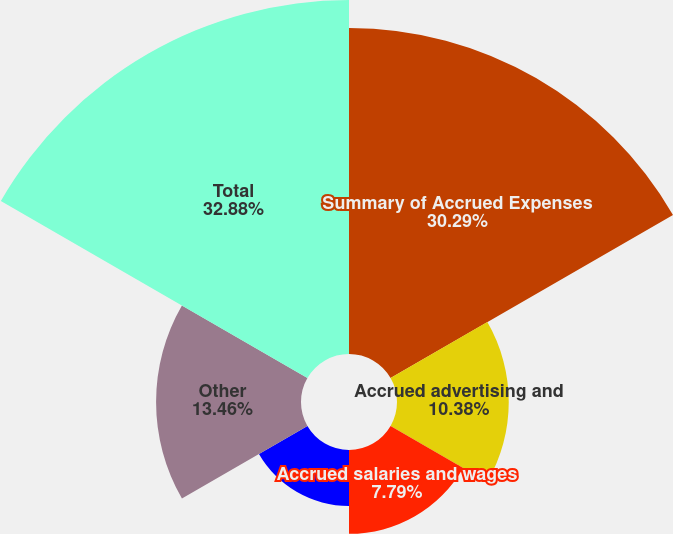<chart> <loc_0><loc_0><loc_500><loc_500><pie_chart><fcel>Summary of Accrued Expenses<fcel>Accrued advertising and<fcel>Accrued salaries and wages<fcel>Accrued quantity discounts<fcel>Other<fcel>Total<nl><fcel>30.29%<fcel>10.38%<fcel>7.79%<fcel>5.2%<fcel>13.46%<fcel>32.88%<nl></chart> 